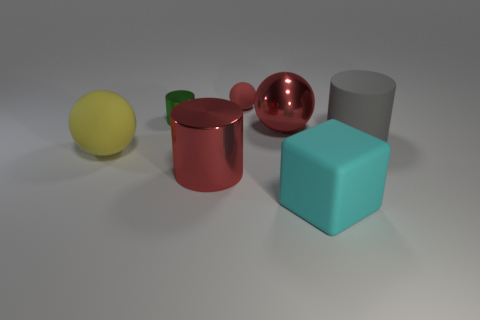Subtract all big cylinders. How many cylinders are left? 1 Add 3 big red balls. How many objects exist? 10 Subtract all balls. How many objects are left? 4 Add 7 red shiny spheres. How many red shiny spheres exist? 8 Subtract 1 green cylinders. How many objects are left? 6 Subtract all small matte cylinders. Subtract all matte cylinders. How many objects are left? 6 Add 7 small metallic cylinders. How many small metallic cylinders are left? 8 